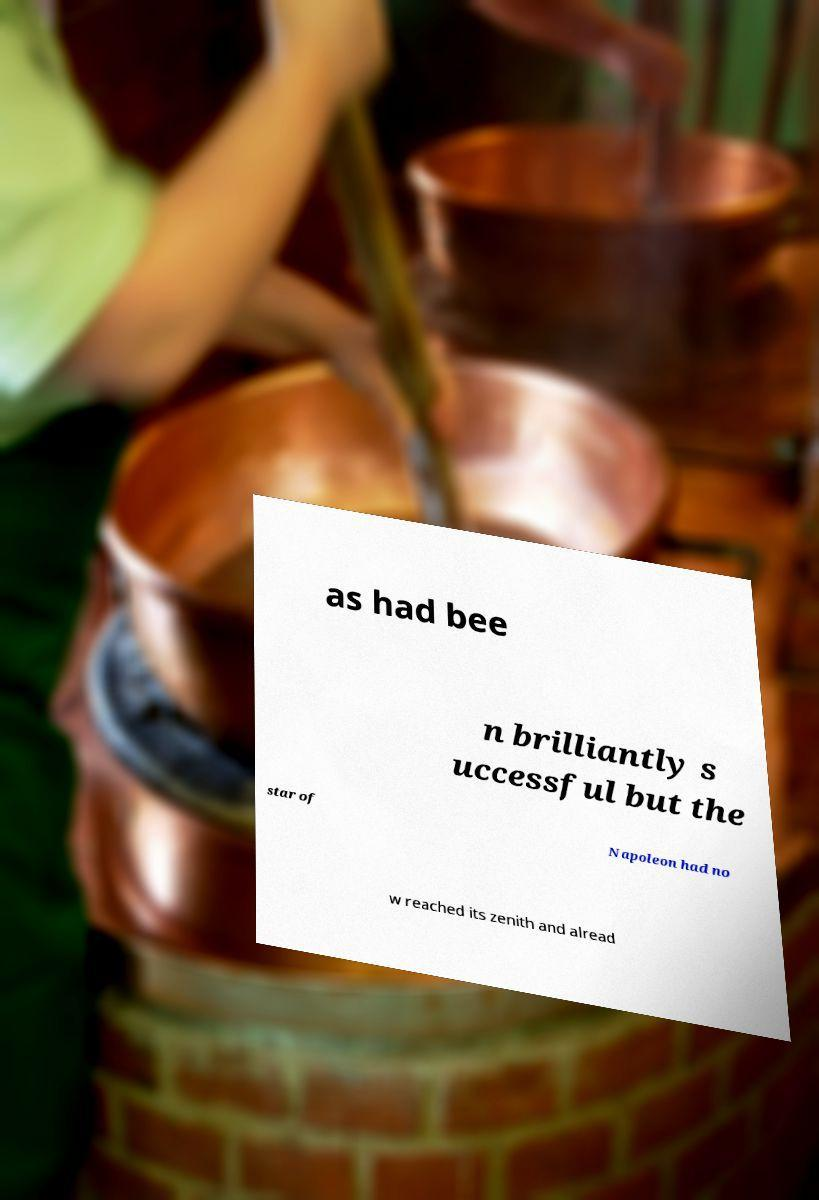There's text embedded in this image that I need extracted. Can you transcribe it verbatim? as had bee n brilliantly s uccessful but the star of Napoleon had no w reached its zenith and alread 